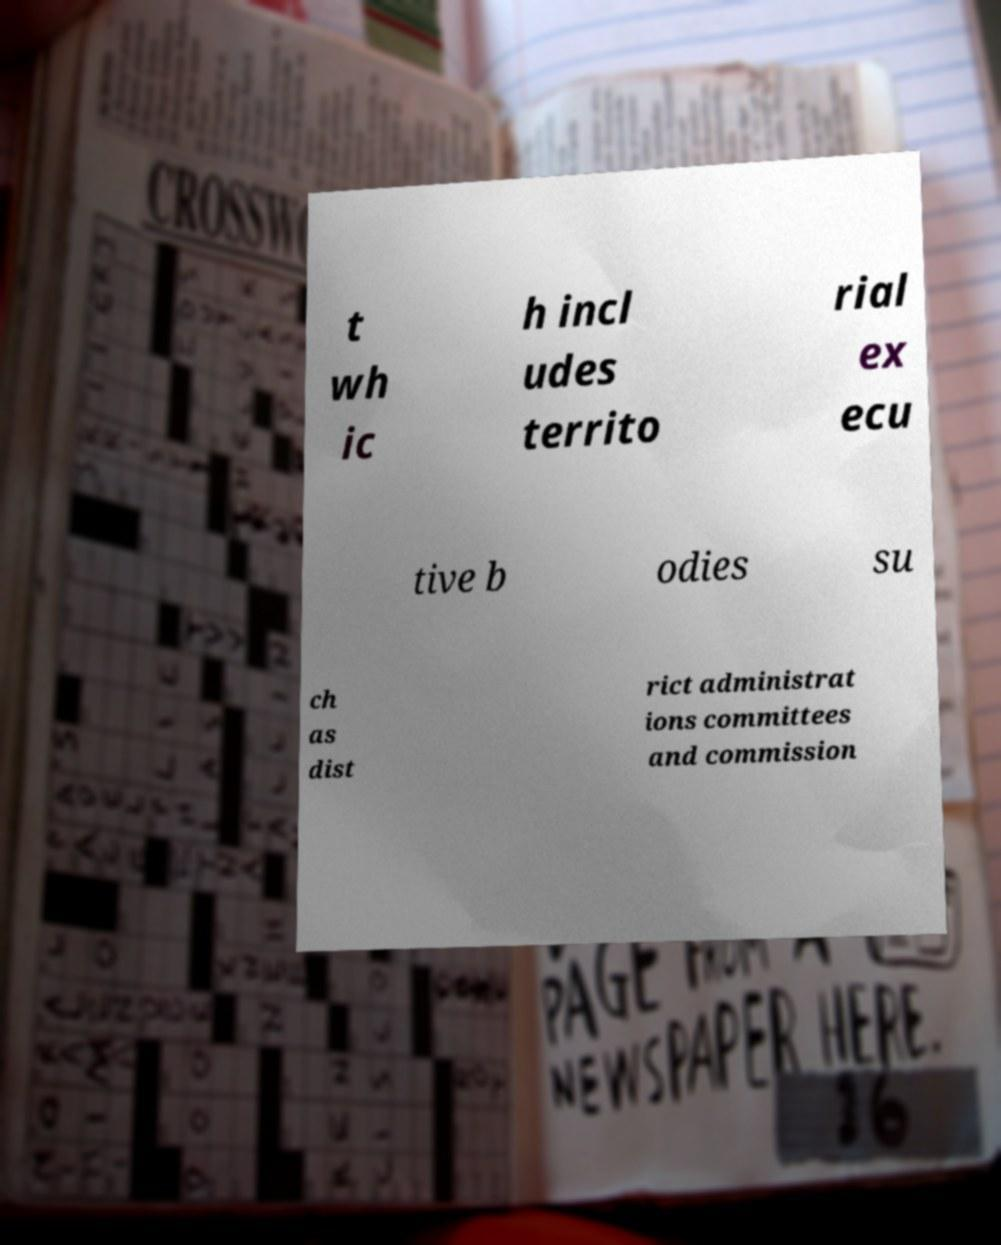Can you accurately transcribe the text from the provided image for me? t wh ic h incl udes territo rial ex ecu tive b odies su ch as dist rict administrat ions committees and commission 